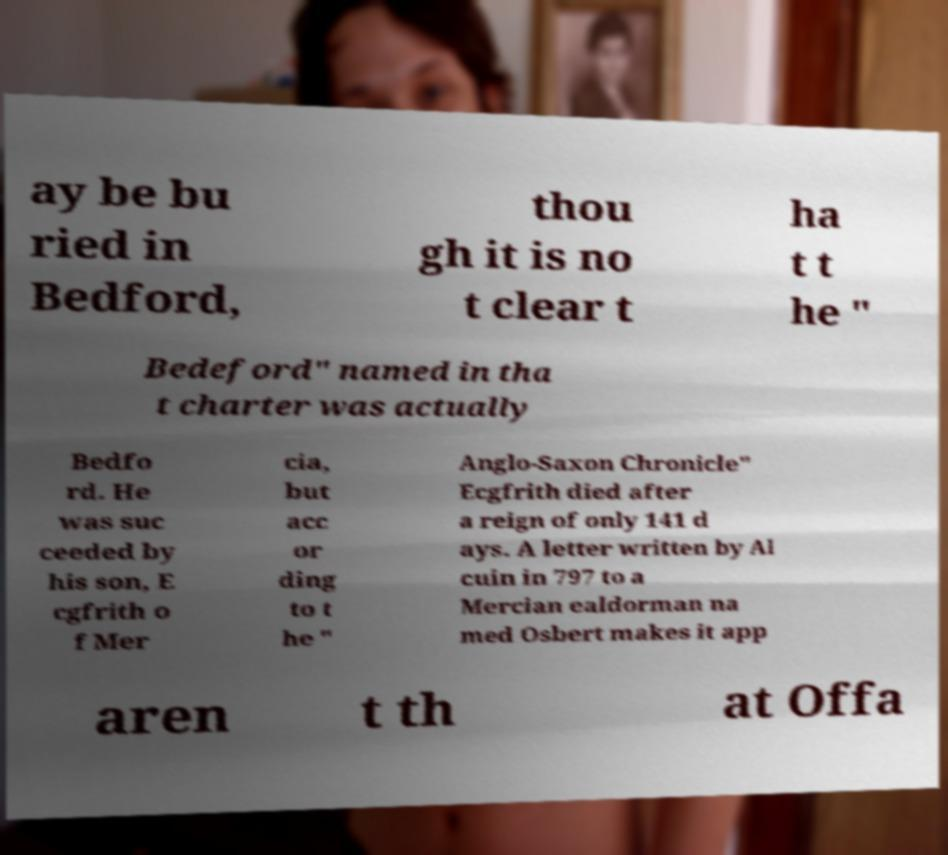Please read and relay the text visible in this image. What does it say? ay be bu ried in Bedford, thou gh it is no t clear t ha t t he " Bedeford" named in tha t charter was actually Bedfo rd. He was suc ceeded by his son, E cgfrith o f Mer cia, but acc or ding to t he " Anglo-Saxon Chronicle" Ecgfrith died after a reign of only 141 d ays. A letter written by Al cuin in 797 to a Mercian ealdorman na med Osbert makes it app aren t th at Offa 